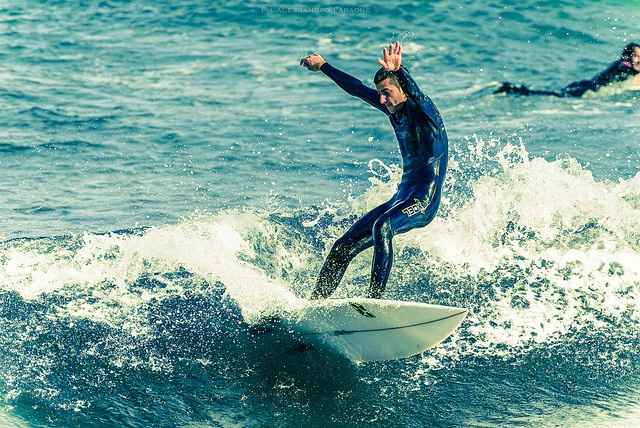Describe the objects in this image and their specific colors. I can see people in lightblue, black, navy, and blue tones, surfboard in lightblue, teal, darkgray, and beige tones, and people in lightblue, black, teal, and navy tones in this image. 